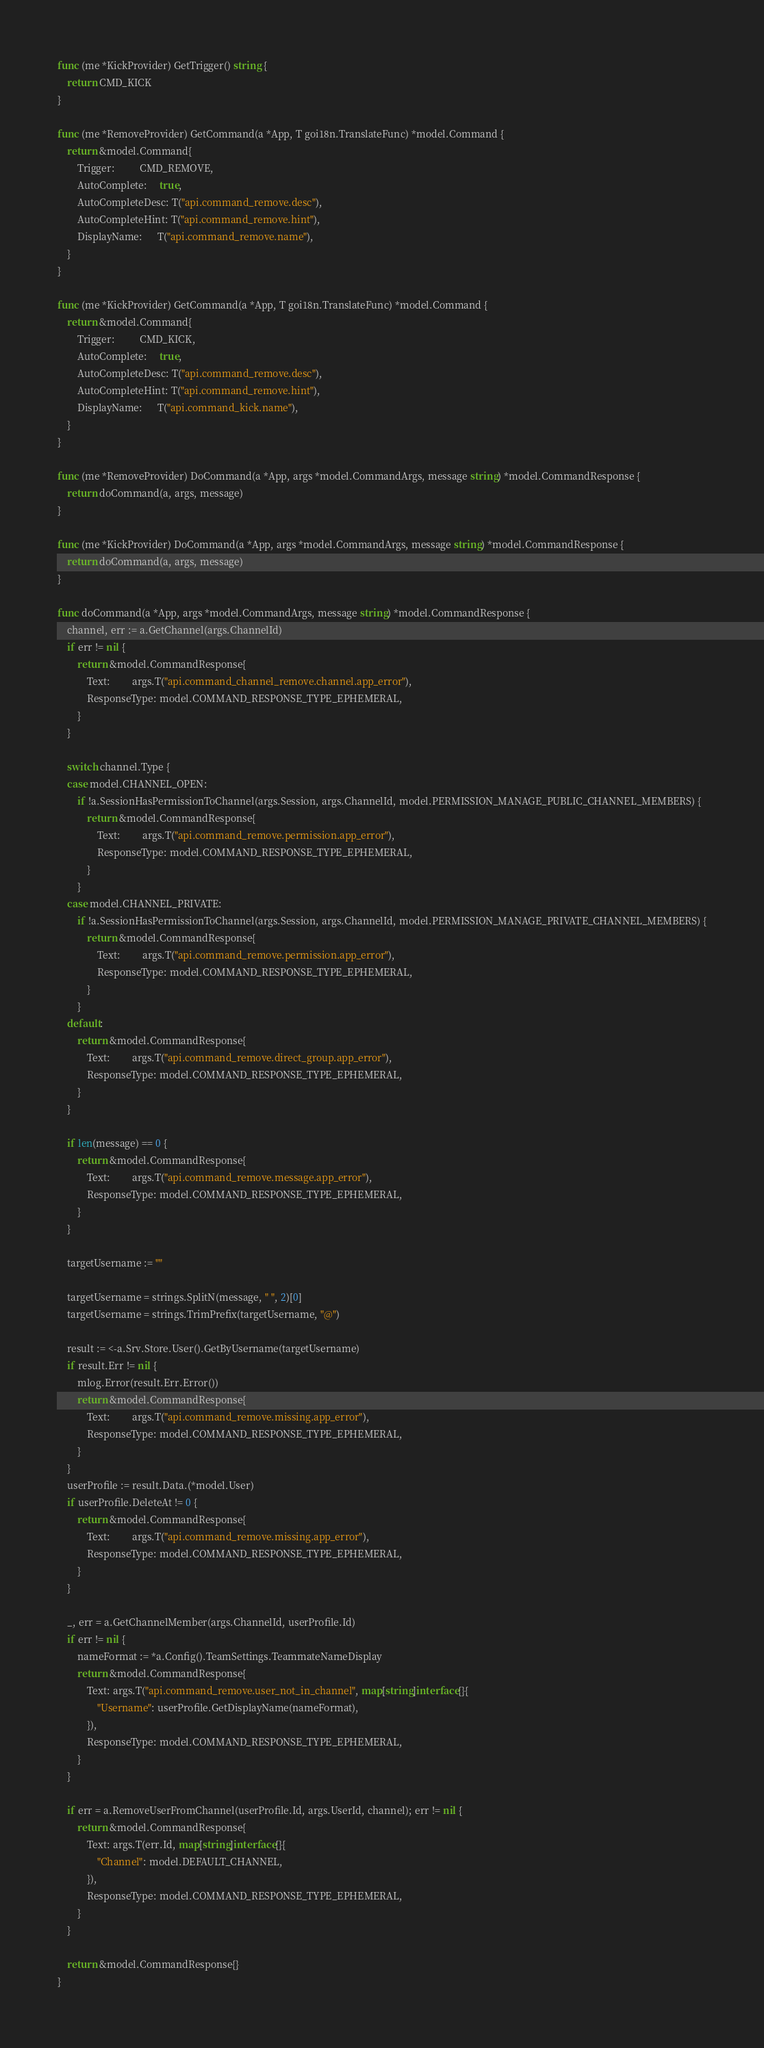Convert code to text. <code><loc_0><loc_0><loc_500><loc_500><_Go_>func (me *KickProvider) GetTrigger() string {
	return CMD_KICK
}

func (me *RemoveProvider) GetCommand(a *App, T goi18n.TranslateFunc) *model.Command {
	return &model.Command{
		Trigger:          CMD_REMOVE,
		AutoComplete:     true,
		AutoCompleteDesc: T("api.command_remove.desc"),
		AutoCompleteHint: T("api.command_remove.hint"),
		DisplayName:      T("api.command_remove.name"),
	}
}

func (me *KickProvider) GetCommand(a *App, T goi18n.TranslateFunc) *model.Command {
	return &model.Command{
		Trigger:          CMD_KICK,
		AutoComplete:     true,
		AutoCompleteDesc: T("api.command_remove.desc"),
		AutoCompleteHint: T("api.command_remove.hint"),
		DisplayName:      T("api.command_kick.name"),
	}
}

func (me *RemoveProvider) DoCommand(a *App, args *model.CommandArgs, message string) *model.CommandResponse {
	return doCommand(a, args, message)
}

func (me *KickProvider) DoCommand(a *App, args *model.CommandArgs, message string) *model.CommandResponse {
	return doCommand(a, args, message)
}

func doCommand(a *App, args *model.CommandArgs, message string) *model.CommandResponse {
	channel, err := a.GetChannel(args.ChannelId)
	if err != nil {
		return &model.CommandResponse{
			Text:         args.T("api.command_channel_remove.channel.app_error"),
			ResponseType: model.COMMAND_RESPONSE_TYPE_EPHEMERAL,
		}
	}

	switch channel.Type {
	case model.CHANNEL_OPEN:
		if !a.SessionHasPermissionToChannel(args.Session, args.ChannelId, model.PERMISSION_MANAGE_PUBLIC_CHANNEL_MEMBERS) {
			return &model.CommandResponse{
				Text:         args.T("api.command_remove.permission.app_error"),
				ResponseType: model.COMMAND_RESPONSE_TYPE_EPHEMERAL,
			}
		}
	case model.CHANNEL_PRIVATE:
		if !a.SessionHasPermissionToChannel(args.Session, args.ChannelId, model.PERMISSION_MANAGE_PRIVATE_CHANNEL_MEMBERS) {
			return &model.CommandResponse{
				Text:         args.T("api.command_remove.permission.app_error"),
				ResponseType: model.COMMAND_RESPONSE_TYPE_EPHEMERAL,
			}
		}
	default:
		return &model.CommandResponse{
			Text:         args.T("api.command_remove.direct_group.app_error"),
			ResponseType: model.COMMAND_RESPONSE_TYPE_EPHEMERAL,
		}
	}

	if len(message) == 0 {
		return &model.CommandResponse{
			Text:         args.T("api.command_remove.message.app_error"),
			ResponseType: model.COMMAND_RESPONSE_TYPE_EPHEMERAL,
		}
	}

	targetUsername := ""

	targetUsername = strings.SplitN(message, " ", 2)[0]
	targetUsername = strings.TrimPrefix(targetUsername, "@")

	result := <-a.Srv.Store.User().GetByUsername(targetUsername)
	if result.Err != nil {
		mlog.Error(result.Err.Error())
		return &model.CommandResponse{
			Text:         args.T("api.command_remove.missing.app_error"),
			ResponseType: model.COMMAND_RESPONSE_TYPE_EPHEMERAL,
		}
	}
	userProfile := result.Data.(*model.User)
	if userProfile.DeleteAt != 0 {
		return &model.CommandResponse{
			Text:         args.T("api.command_remove.missing.app_error"),
			ResponseType: model.COMMAND_RESPONSE_TYPE_EPHEMERAL,
		}
	}

	_, err = a.GetChannelMember(args.ChannelId, userProfile.Id)
	if err != nil {
		nameFormat := *a.Config().TeamSettings.TeammateNameDisplay
		return &model.CommandResponse{
			Text: args.T("api.command_remove.user_not_in_channel", map[string]interface{}{
				"Username": userProfile.GetDisplayName(nameFormat),
			}),
			ResponseType: model.COMMAND_RESPONSE_TYPE_EPHEMERAL,
		}
	}

	if err = a.RemoveUserFromChannel(userProfile.Id, args.UserId, channel); err != nil {
		return &model.CommandResponse{
			Text: args.T(err.Id, map[string]interface{}{
				"Channel": model.DEFAULT_CHANNEL,
			}),
			ResponseType: model.COMMAND_RESPONSE_TYPE_EPHEMERAL,
		}
	}

	return &model.CommandResponse{}
}
</code> 